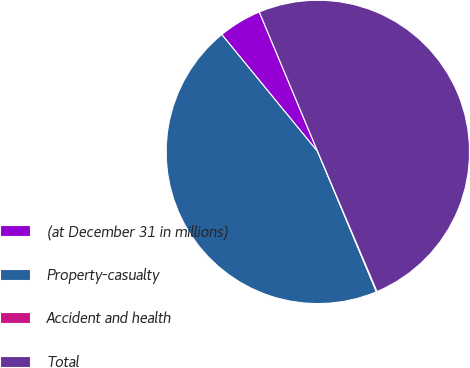Convert chart. <chart><loc_0><loc_0><loc_500><loc_500><pie_chart><fcel>(at December 31 in millions)<fcel>Property-casualty<fcel>Accident and health<fcel>Total<nl><fcel>4.61%<fcel>45.39%<fcel>0.07%<fcel>49.93%<nl></chart> 